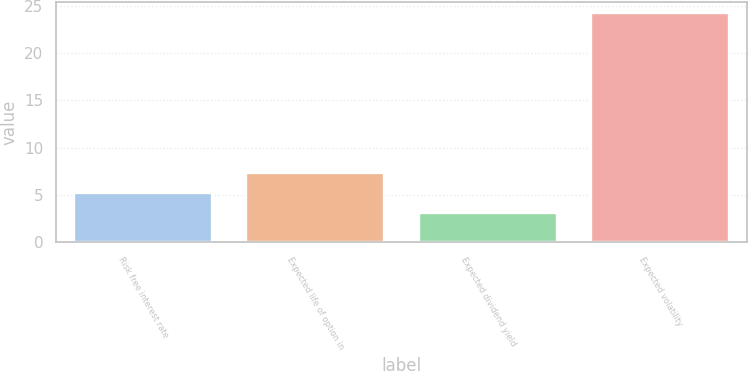<chart> <loc_0><loc_0><loc_500><loc_500><bar_chart><fcel>Risk free interest rate<fcel>Expected life of option in<fcel>Expected dividend yield<fcel>Expected volatility<nl><fcel>5.21<fcel>7.32<fcel>3.1<fcel>24.2<nl></chart> 